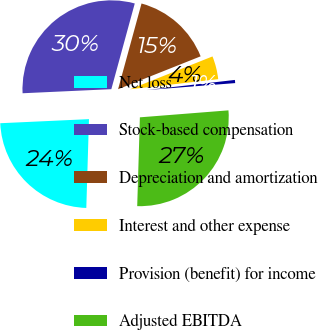Convert chart. <chart><loc_0><loc_0><loc_500><loc_500><pie_chart><fcel>Net loss<fcel>Stock-based compensation<fcel>Depreciation and amortization<fcel>Interest and other expense<fcel>Provision (benefit) for income<fcel>Adjusted EBITDA<nl><fcel>23.79%<fcel>29.98%<fcel>14.72%<fcel>4.21%<fcel>0.57%<fcel>26.73%<nl></chart> 